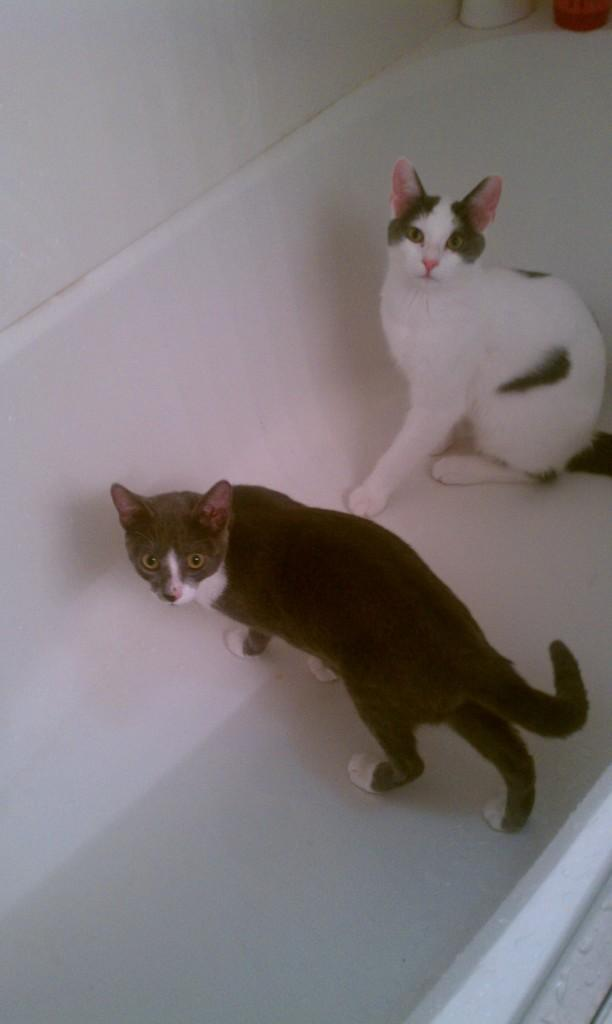How many cats are in the image? There are two cats in the image. What are the colors of the cats? One cat is white in color, and the other cat is black in color. Where are the cats located in the image? Both cats are on the surface in the image. What type of credit can be seen being given to the cats in the image? There is no credit being given to the cats in the image, as it is a simple image of two cats on a surface. 